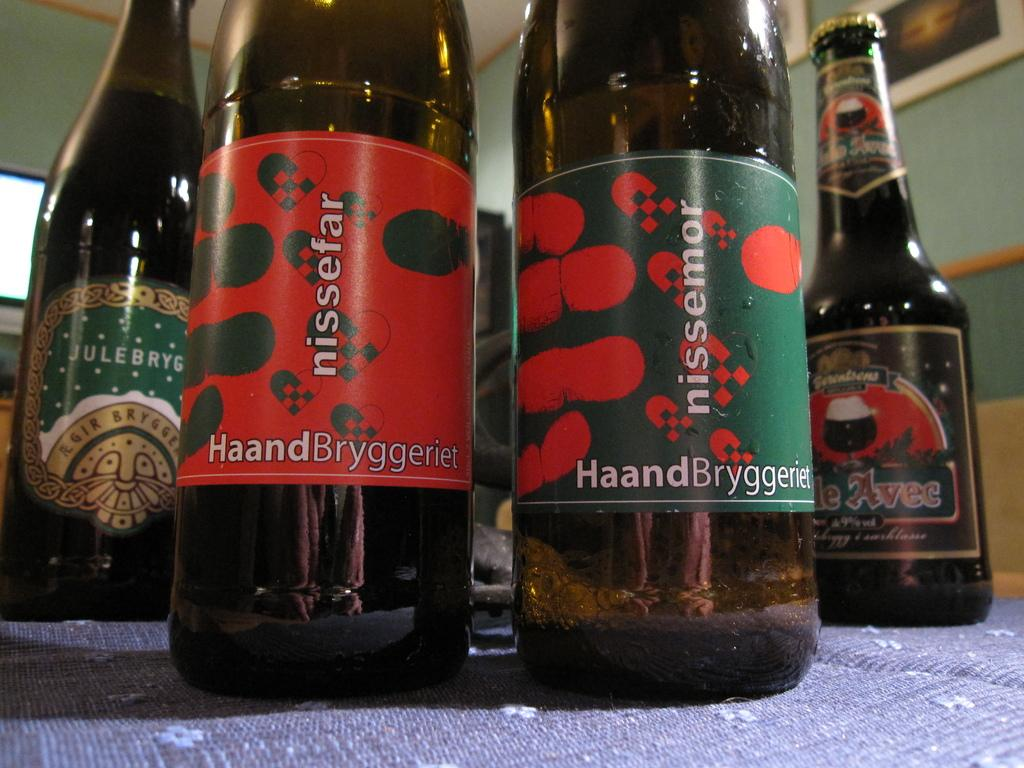<image>
Share a concise interpretation of the image provided. the word haand that is on a wine bottle 